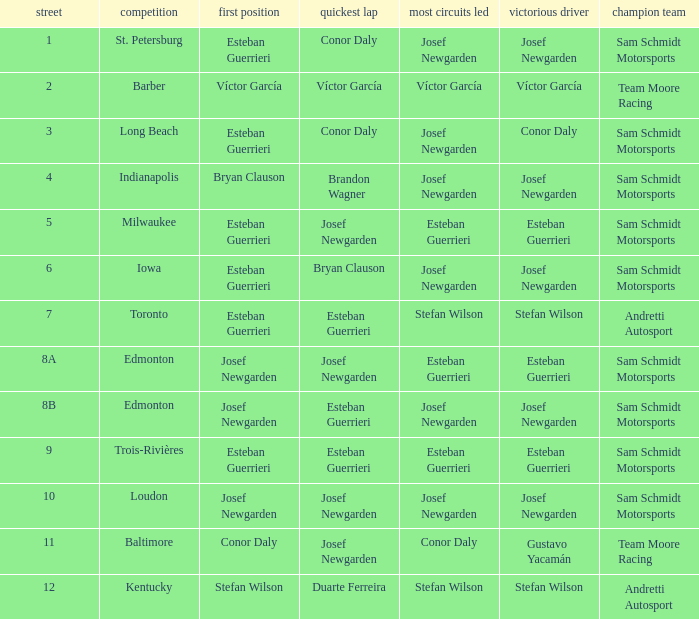Who had the fastest lap(s) when stefan wilson had the pole? Duarte Ferreira. 